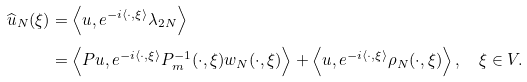<formula> <loc_0><loc_0><loc_500><loc_500>\widehat { u } _ { N } ( \xi ) & = \left \langle u , e ^ { - i \langle \cdot , \xi \rangle } \lambda _ { 2 N } \right \rangle \\ & = \left \langle P u , e ^ { - i \langle \cdot , \xi \rangle } P _ { m } ^ { - 1 } ( \cdot , \xi ) w _ { N } ( \cdot , \xi ) \right \rangle + \left \langle u , e ^ { - i \langle \cdot , \xi \rangle } \rho _ { N } ( \cdot , \xi ) \right \rangle , \quad \xi \in V .</formula> 